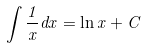<formula> <loc_0><loc_0><loc_500><loc_500>\int \frac { 1 } { x } d x = \ln x + C</formula> 